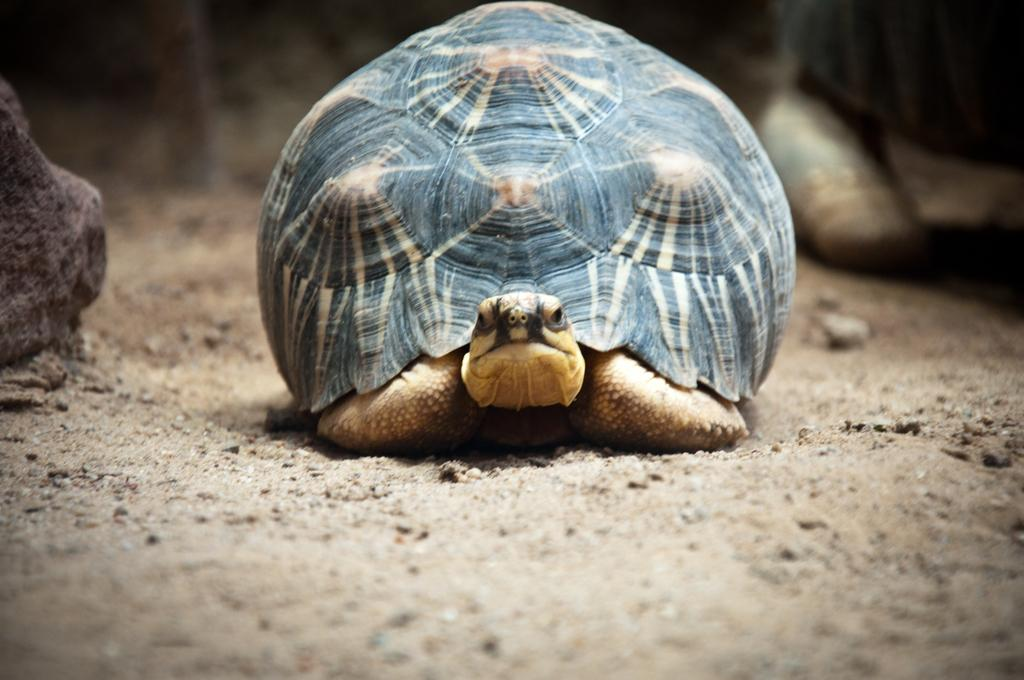What type of animal is present in the image? There is a tortoise in the image. Where is the tortoise located? The tortoise is on the ground. Can you hear the tortoise's ear in the image? There is no ear present in the image, as tortoises do not have external ears. 